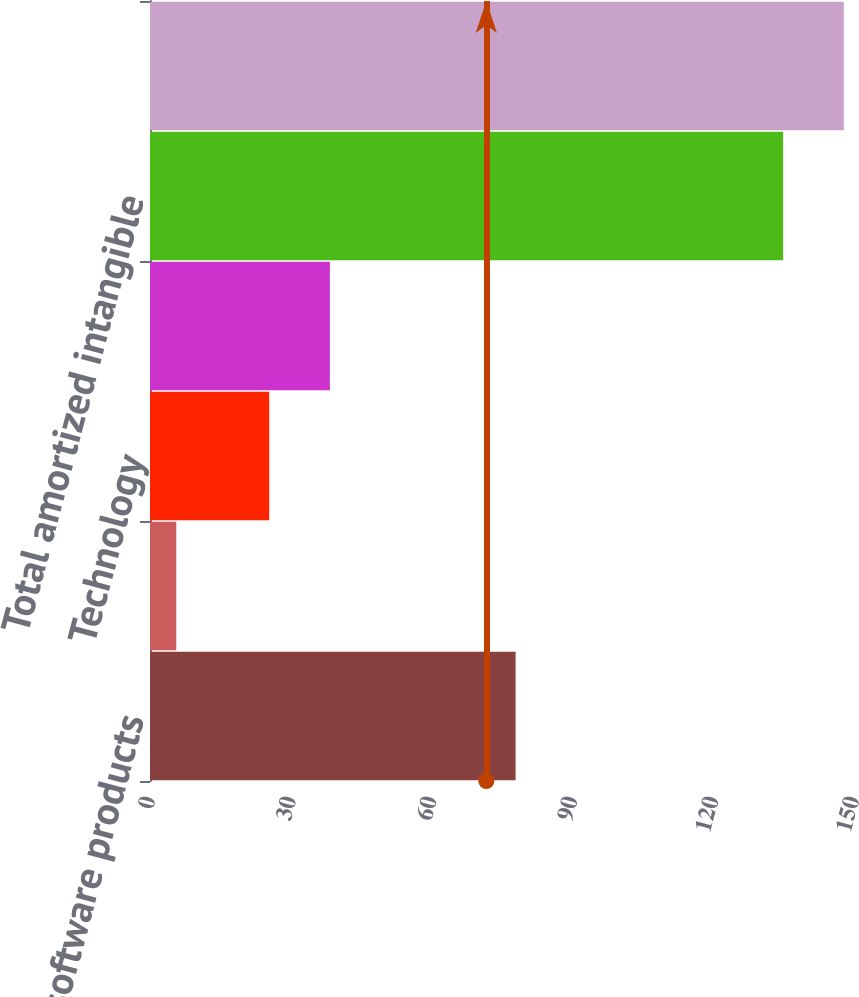<chart> <loc_0><loc_0><loc_500><loc_500><bar_chart><fcel>Computer software products<fcel>Customer relationships<fcel>Technology<fcel>Other<fcel>Total amortized intangible<fcel>Total<nl><fcel>77.9<fcel>5.6<fcel>25.4<fcel>38.33<fcel>134.9<fcel>147.83<nl></chart> 